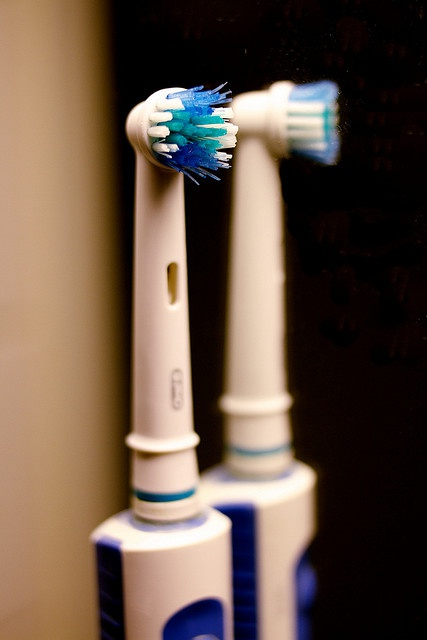Describe the objects in this image and their specific colors. I can see toothbrush in tan, ivory, and black tones and toothbrush in tan, ivory, and black tones in this image. 